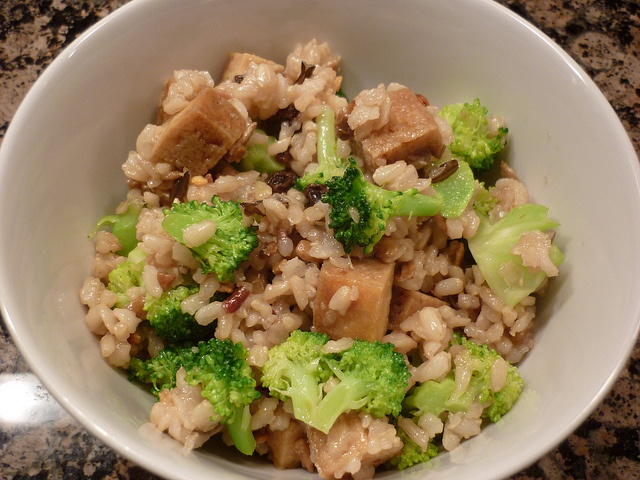Describe the objects in this image and their specific colors. I can see bowl in tan, black, and gray tones, broccoli in black, khaki, and olive tones, broccoli in black, olive, and darkgreen tones, broccoli in black, tan, and olive tones, and broccoli in black, olive, and darkgreen tones in this image. 